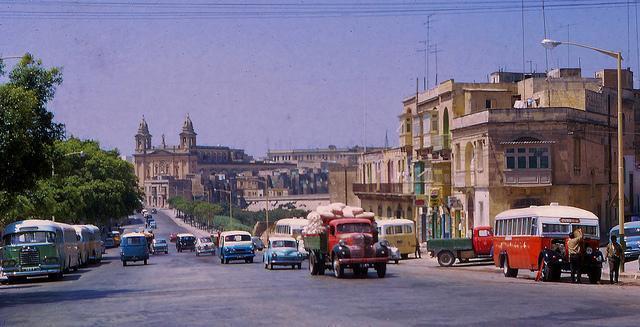How many buses are there?
Give a very brief answer. 2. How many sheep are facing forward?
Give a very brief answer. 0. 